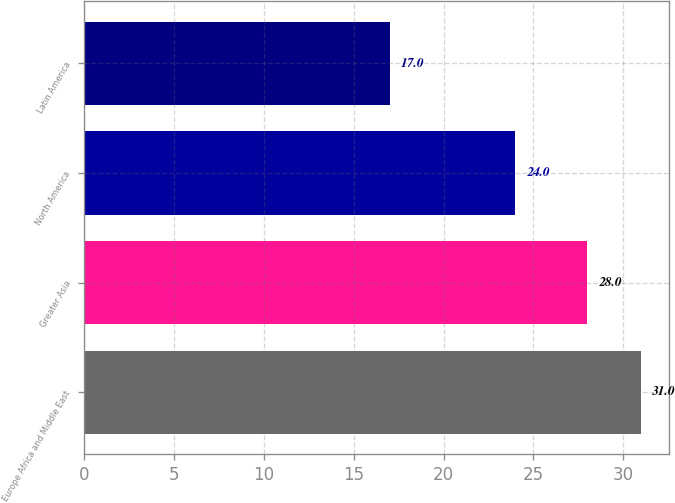Convert chart to OTSL. <chart><loc_0><loc_0><loc_500><loc_500><bar_chart><fcel>Europe Africa and Middle East<fcel>Greater Asia<fcel>North America<fcel>Latin America<nl><fcel>31<fcel>28<fcel>24<fcel>17<nl></chart> 